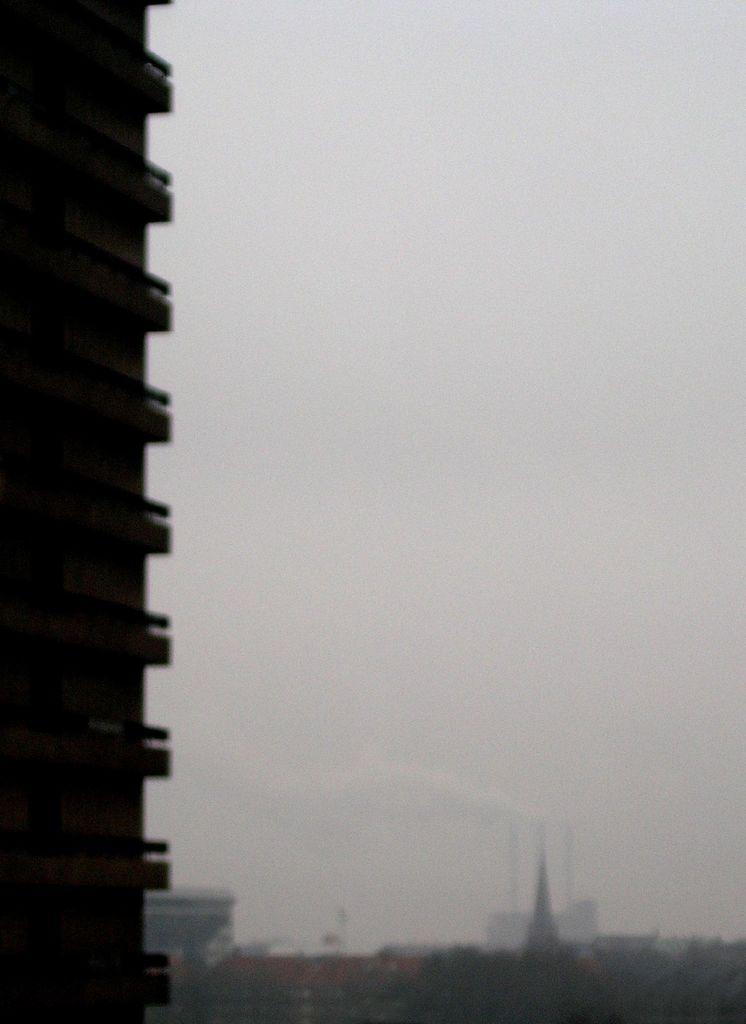How would you summarize this image in a sentence or two? In this image we can see a few buildings, on the left side of the image we can see a building truncated, in the background we can see the sky. 